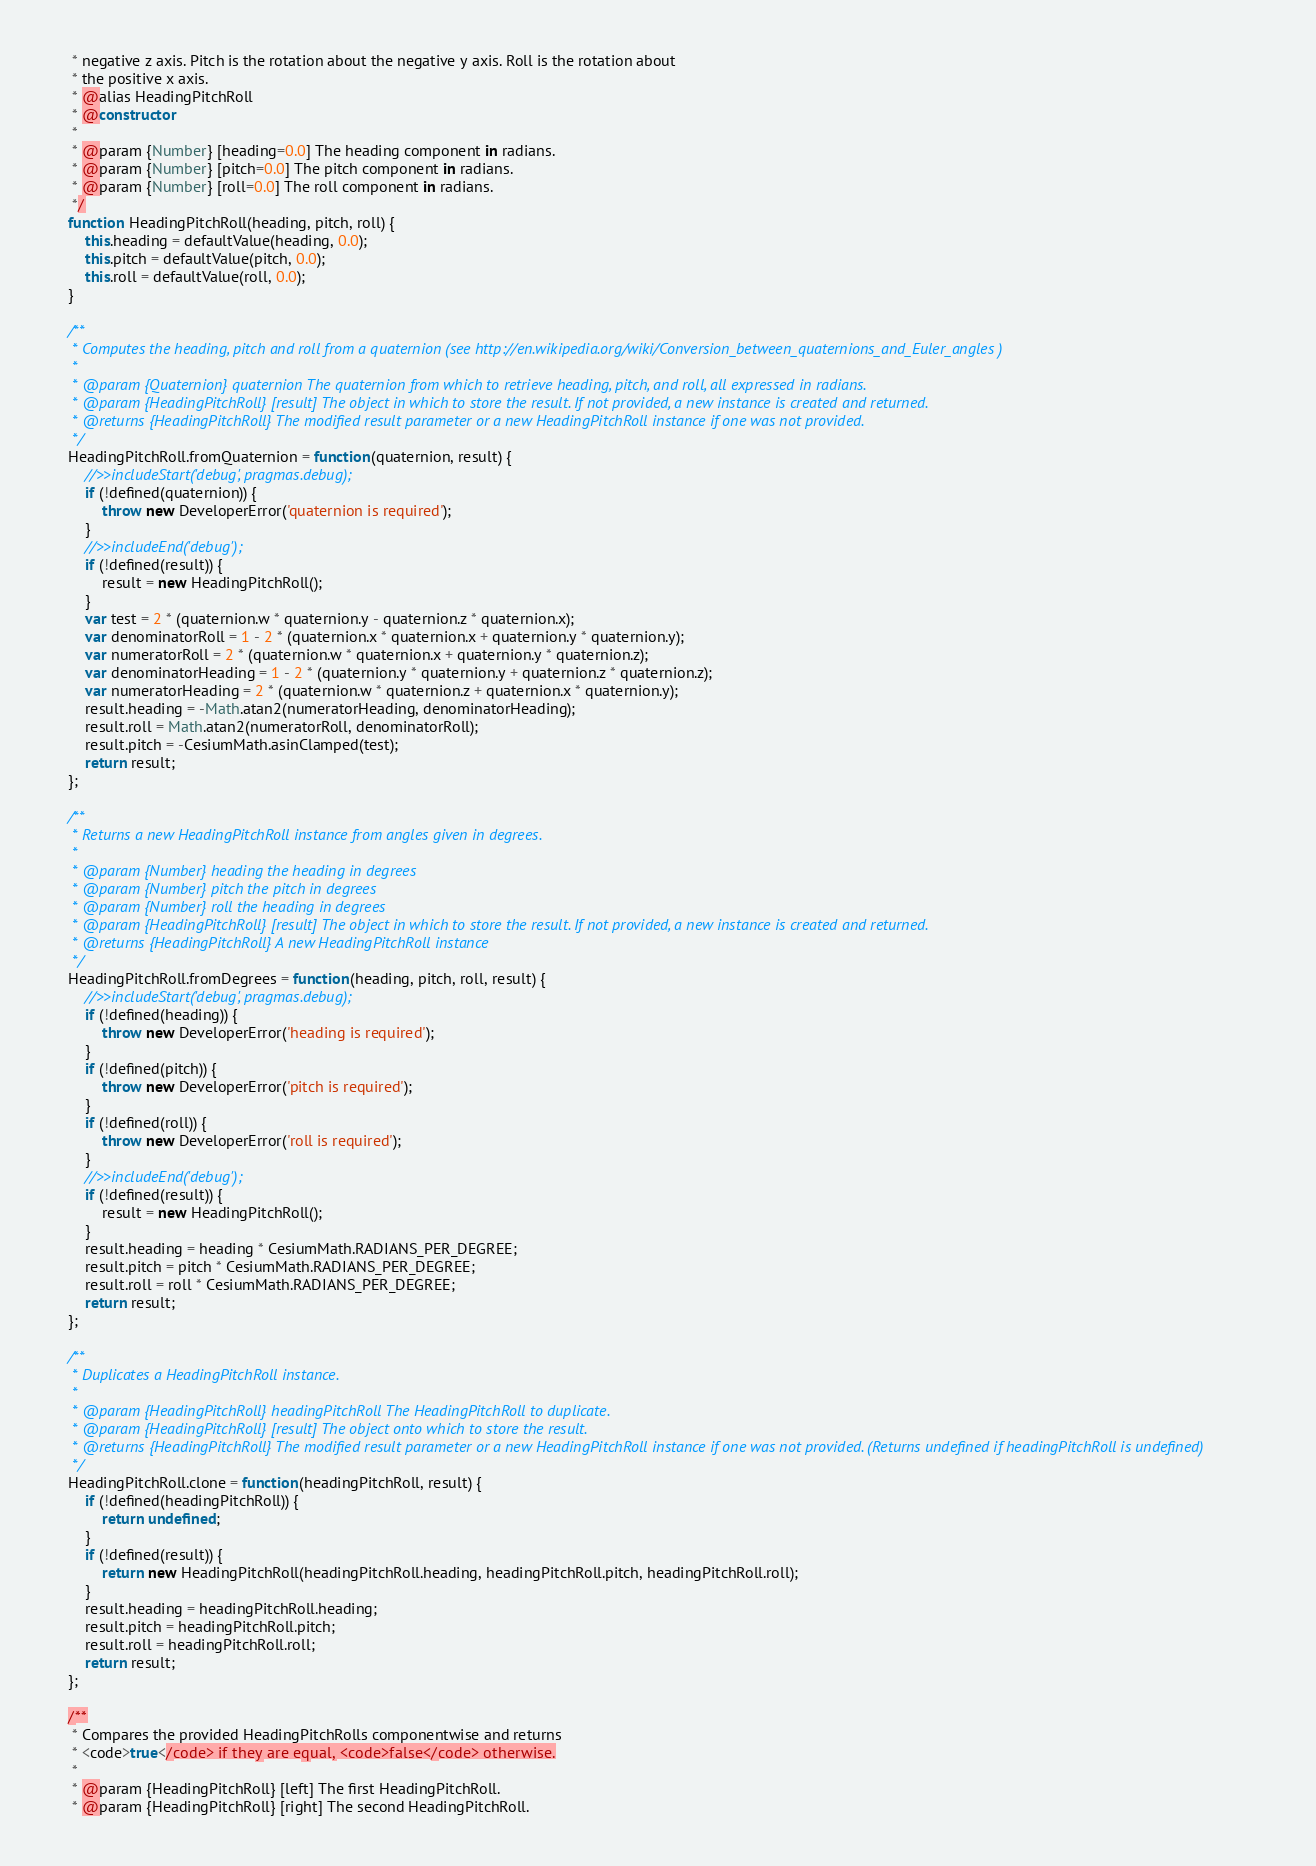<code> <loc_0><loc_0><loc_500><loc_500><_JavaScript_>     * negative z axis. Pitch is the rotation about the negative y axis. Roll is the rotation about
     * the positive x axis.
     * @alias HeadingPitchRoll
     * @constructor
     *
     * @param {Number} [heading=0.0] The heading component in radians.
     * @param {Number} [pitch=0.0] The pitch component in radians.
     * @param {Number} [roll=0.0] The roll component in radians.
     */
    function HeadingPitchRoll(heading, pitch, roll) {
        this.heading = defaultValue(heading, 0.0);
        this.pitch = defaultValue(pitch, 0.0);
        this.roll = defaultValue(roll, 0.0);
    }

    /**
     * Computes the heading, pitch and roll from a quaternion (see http://en.wikipedia.org/wiki/Conversion_between_quaternions_and_Euler_angles )
     *
     * @param {Quaternion} quaternion The quaternion from which to retrieve heading, pitch, and roll, all expressed in radians.
     * @param {HeadingPitchRoll} [result] The object in which to store the result. If not provided, a new instance is created and returned.
     * @returns {HeadingPitchRoll} The modified result parameter or a new HeadingPitchRoll instance if one was not provided.
     */
    HeadingPitchRoll.fromQuaternion = function(quaternion, result) {
        //>>includeStart('debug', pragmas.debug);
        if (!defined(quaternion)) {
            throw new DeveloperError('quaternion is required');
        }
        //>>includeEnd('debug');
        if (!defined(result)) {
            result = new HeadingPitchRoll();
        }
        var test = 2 * (quaternion.w * quaternion.y - quaternion.z * quaternion.x);
        var denominatorRoll = 1 - 2 * (quaternion.x * quaternion.x + quaternion.y * quaternion.y);
        var numeratorRoll = 2 * (quaternion.w * quaternion.x + quaternion.y * quaternion.z);
        var denominatorHeading = 1 - 2 * (quaternion.y * quaternion.y + quaternion.z * quaternion.z);
        var numeratorHeading = 2 * (quaternion.w * quaternion.z + quaternion.x * quaternion.y);
        result.heading = -Math.atan2(numeratorHeading, denominatorHeading);
        result.roll = Math.atan2(numeratorRoll, denominatorRoll);
        result.pitch = -CesiumMath.asinClamped(test);
        return result;
    };

    /**
     * Returns a new HeadingPitchRoll instance from angles given in degrees.
     *
     * @param {Number} heading the heading in degrees
     * @param {Number} pitch the pitch in degrees
     * @param {Number} roll the heading in degrees
     * @param {HeadingPitchRoll} [result] The object in which to store the result. If not provided, a new instance is created and returned.
     * @returns {HeadingPitchRoll} A new HeadingPitchRoll instance
     */
    HeadingPitchRoll.fromDegrees = function(heading, pitch, roll, result) {
        //>>includeStart('debug', pragmas.debug);
        if (!defined(heading)) {
            throw new DeveloperError('heading is required');
        }
        if (!defined(pitch)) {
            throw new DeveloperError('pitch is required');
        }
        if (!defined(roll)) {
            throw new DeveloperError('roll is required');
        }
        //>>includeEnd('debug');
        if (!defined(result)) {
            result = new HeadingPitchRoll();
        }
        result.heading = heading * CesiumMath.RADIANS_PER_DEGREE;
        result.pitch = pitch * CesiumMath.RADIANS_PER_DEGREE;
        result.roll = roll * CesiumMath.RADIANS_PER_DEGREE;
        return result;
    };

    /**
     * Duplicates a HeadingPitchRoll instance.
     *
     * @param {HeadingPitchRoll} headingPitchRoll The HeadingPitchRoll to duplicate.
     * @param {HeadingPitchRoll} [result] The object onto which to store the result.
     * @returns {HeadingPitchRoll} The modified result parameter or a new HeadingPitchRoll instance if one was not provided. (Returns undefined if headingPitchRoll is undefined)
     */
    HeadingPitchRoll.clone = function(headingPitchRoll, result) {
        if (!defined(headingPitchRoll)) {
            return undefined;
        }
        if (!defined(result)) {
            return new HeadingPitchRoll(headingPitchRoll.heading, headingPitchRoll.pitch, headingPitchRoll.roll);
        }
        result.heading = headingPitchRoll.heading;
        result.pitch = headingPitchRoll.pitch;
        result.roll = headingPitchRoll.roll;
        return result;
    };

    /**
     * Compares the provided HeadingPitchRolls componentwise and returns
     * <code>true</code> if they are equal, <code>false</code> otherwise.
     *
     * @param {HeadingPitchRoll} [left] The first HeadingPitchRoll.
     * @param {HeadingPitchRoll} [right] The second HeadingPitchRoll.</code> 